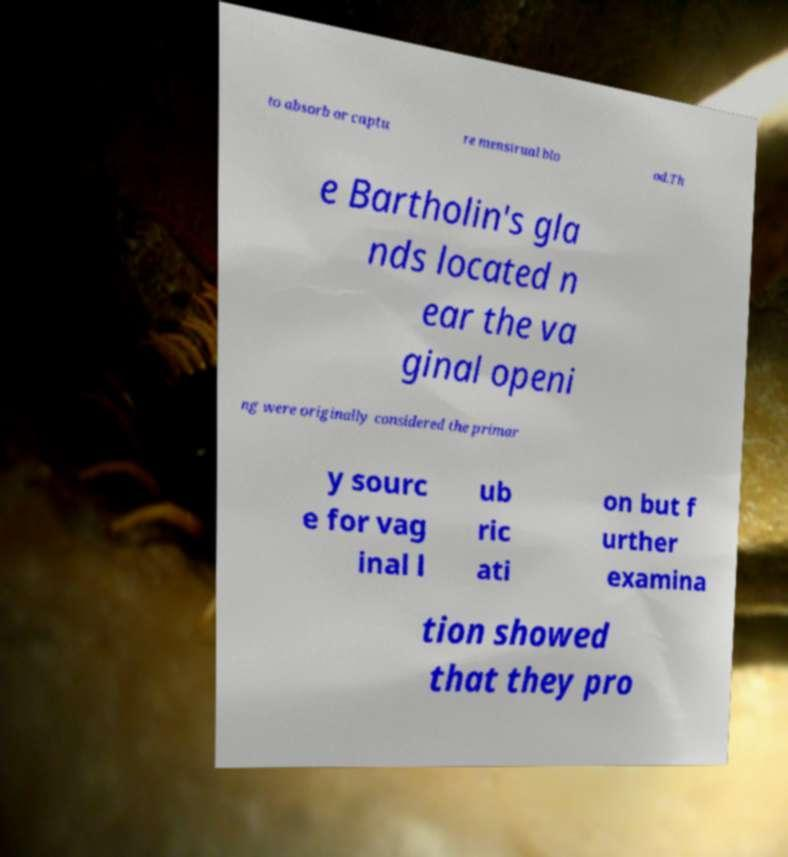Could you extract and type out the text from this image? to absorb or captu re menstrual blo od.Th e Bartholin's gla nds located n ear the va ginal openi ng were originally considered the primar y sourc e for vag inal l ub ric ati on but f urther examina tion showed that they pro 